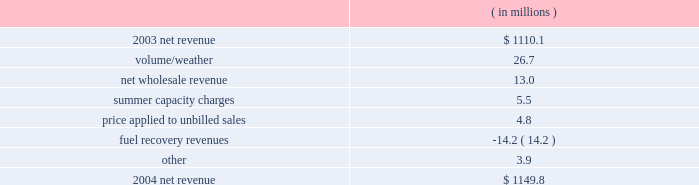Entergy gulf states , inc .
Management's financial discussion and analysis .
The volume/weather variance resulted primarily from an increase of 1179 gwh in electricity usage in the industrial sector .
Billed usage also increased a total of 291 gwh in the residential , commercial , and governmental sectors .
The increase in net wholesale revenue is primarily due to an increase in sales volume to municipal and co-op customers .
Summer capacity charges variance is due to the amortization in 2003 of deferred capacity charges for the summer of 2001 compared to the absence of the amortization in 2004 .
The amortization of these capacity charges began in june 2002 and ended in may 2003 .
The price applied to unbilled sales variance resulted primarily from an increase in the fuel price applied to unbilled sales .
Fuel recovery revenues represent an under-recovery of fuel charges that are recovered in base rates .
Entergy gulf states recorded $ 22.6 million of provisions in 2004 for potential rate refunds .
These provisions are not included in the net revenue table above because they are more than offset by provisions recorded in 2003 .
Gross operating revenues , fuel and purchased power expenses , and other regulatory credits gross operating revenues increased primarily due to an increase of $ 187.8 million in fuel cost recovery revenues as a result of higher fuel rates in both the louisiana and texas jurisdictions .
The increases in volume/weather and wholesale revenue , discussed above , also contributed to the increase .
Fuel and purchased power expenses increased primarily due to : 2022 increased recovery of deferred fuel costs due to higher fuel rates ; 2022 increases in the market prices of natural gas , coal , and purchased power ; and 2022 an increase in electricity usage , discussed above .
Other regulatory credits increased primarily due to the amortization in 2003 of deferred capacity charges for the summer of 2001 compared to the absence of amortization in 2004 .
The amortization of these charges began in june 2002 and ended in may 2003 .
2003 compared to 2002 net revenue , which is entergy gulf states' measure of gross margin , consists of operating revenues net of : 1 ) fuel , fuel-related , and purchased power expenses and 2 ) other regulatory credits .
Following is an analysis of the change in net revenue comparing 2003 to 2002. .
What is the percent change in net revenue from 2003 to 2004? 
Computations: ((1149.8 - 1110.1) / 1110.1)
Answer: 0.03576. 